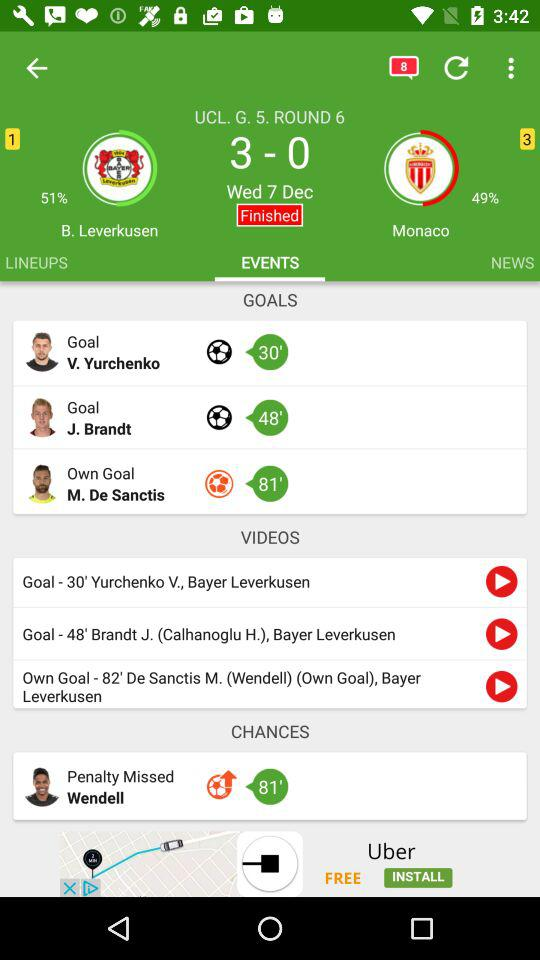Which tab is selected? The selected tab is "EVENTS". 